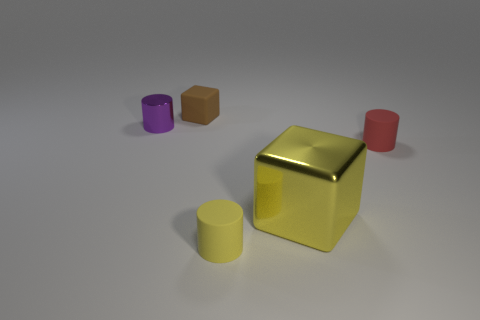Add 4 small brown matte objects. How many objects exist? 9 Subtract all blocks. How many objects are left? 3 Subtract 0 blue balls. How many objects are left? 5 Subtract all large brown rubber blocks. Subtract all rubber cylinders. How many objects are left? 3 Add 4 shiny things. How many shiny things are left? 6 Add 3 tiny yellow things. How many tiny yellow things exist? 4 